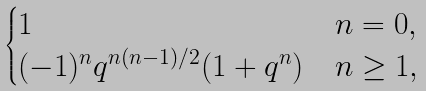Convert formula to latex. <formula><loc_0><loc_0><loc_500><loc_500>\begin{cases} 1 & n = 0 , \\ ( - 1 ) ^ { n } q ^ { n ( n - 1 ) / 2 } ( 1 + q ^ { n } ) & n \geq 1 , \end{cases}</formula> 